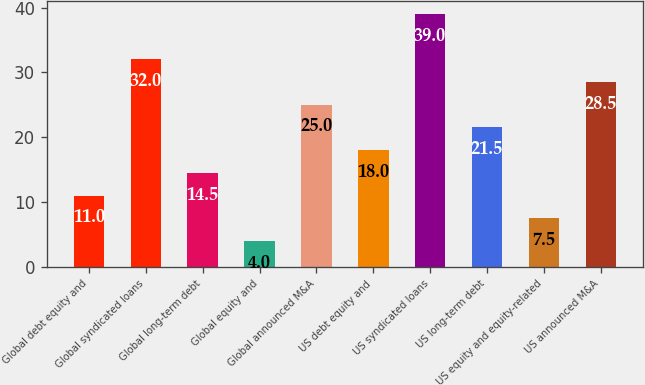Convert chart. <chart><loc_0><loc_0><loc_500><loc_500><bar_chart><fcel>Global debt equity and<fcel>Global syndicated loans<fcel>Global long-term debt<fcel>Global equity and<fcel>Global announced M&A<fcel>US debt equity and<fcel>US syndicated loans<fcel>US long-term debt<fcel>US equity and equity-related<fcel>US announced M&A<nl><fcel>11<fcel>32<fcel>14.5<fcel>4<fcel>25<fcel>18<fcel>39<fcel>21.5<fcel>7.5<fcel>28.5<nl></chart> 